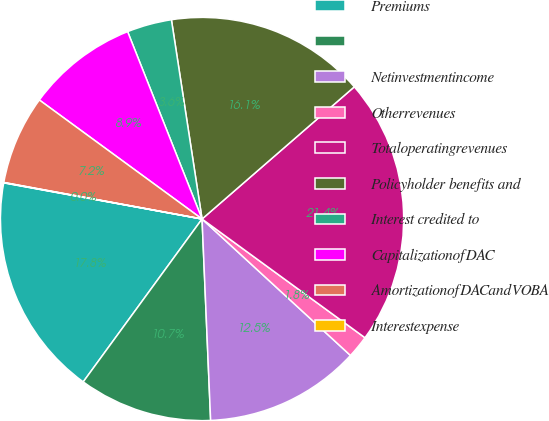<chart> <loc_0><loc_0><loc_500><loc_500><pie_chart><fcel>Premiums<fcel>Unnamed: 1<fcel>Netinvestmentincome<fcel>Otherrevenues<fcel>Totaloperatingrevenues<fcel>Policyholder benefits and<fcel>Interest credited to<fcel>CapitalizationofDAC<fcel>AmortizationofDACandVOBA<fcel>Interestexpense<nl><fcel>17.84%<fcel>10.71%<fcel>12.49%<fcel>1.81%<fcel>21.4%<fcel>16.05%<fcel>3.59%<fcel>8.93%<fcel>7.15%<fcel>0.03%<nl></chart> 